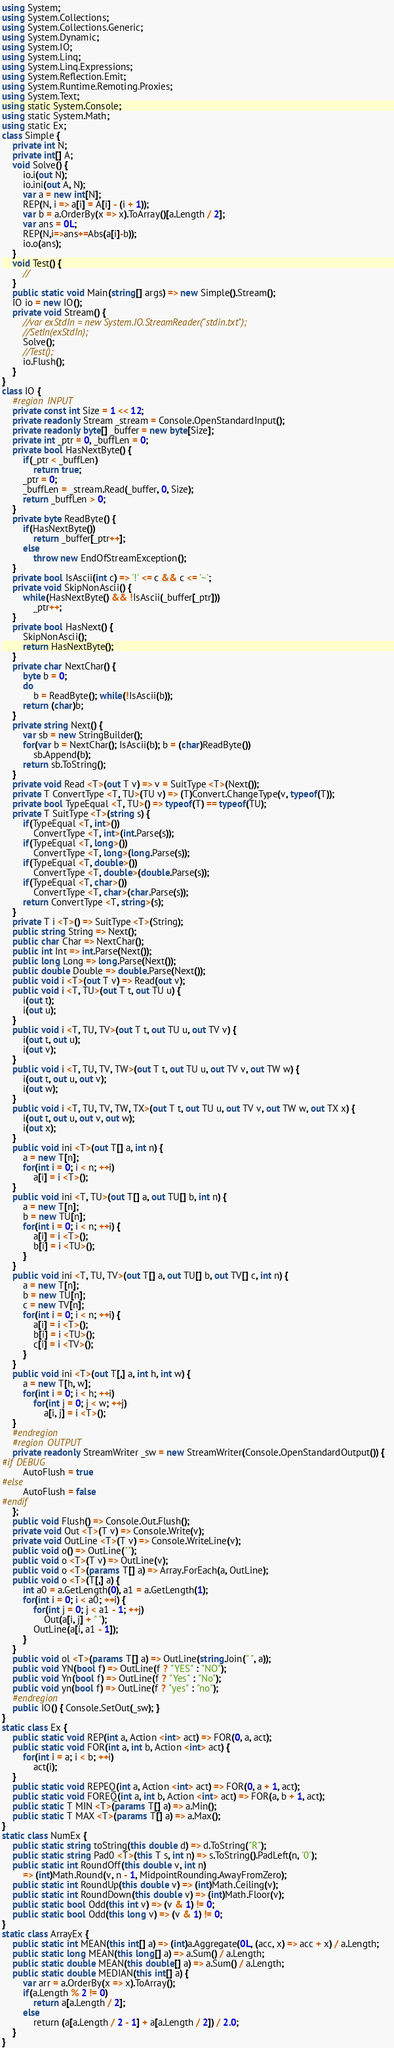Convert code to text. <code><loc_0><loc_0><loc_500><loc_500><_C#_>using System;
using System.Collections;
using System.Collections.Generic;
using System.Dynamic;
using System.IO;
using System.Linq;
using System.Linq.Expressions;
using System.Reflection.Emit;
using System.Runtime.Remoting.Proxies;
using System.Text;
using static System.Console;
using static System.Math;
using static Ex;
class Simple {
    private int N;
    private int[] A;
    void Solve() {
        io.i(out N);
        io.ini(out A, N);
        var a = new int[N];
        REP(N, i => a[i] = A[i] - (i + 1));
        var b = a.OrderBy(x => x).ToArray()[a.Length / 2];
        var ans = 0L;
        REP(N,i=>ans+=Abs(a[i]-b));
        io.o(ans);        
    }
    void Test() {
        //
    }
    public static void Main(string[] args) => new Simple().Stream();
    IO io = new IO();
    private void Stream() {
        //var exStdIn = new System.IO.StreamReader("stdin.txt");
        //SetIn(exStdIn);
        Solve();
        //Test();
        io.Flush();
    }
}
class IO {
    #region INPUT
    private const int Size = 1 << 12;
    private readonly Stream _stream = Console.OpenStandardInput();
    private readonly byte[] _buffer = new byte[Size];
    private int _ptr = 0, _buffLen = 0;
    private bool HasNextByte() {
        if(_ptr < _buffLen)
            return true;
        _ptr = 0;
        _buffLen = _stream.Read(_buffer, 0, Size);
        return _buffLen > 0;
    }
    private byte ReadByte() {
        if(HasNextByte())
            return _buffer[_ptr++];
        else
            throw new EndOfStreamException();
    }
    private bool IsAscii(int c) => '!' <= c && c <= '~';
    private void SkipNonAscii() {
        while(HasNextByte() && !IsAscii(_buffer[_ptr]))
            _ptr++;
    }
    private bool HasNext() {
        SkipNonAscii();
        return HasNextByte();
    }
    private char NextChar() {
        byte b = 0;
        do
            b = ReadByte(); while(!IsAscii(b));
        return (char)b;
    }
    private string Next() {
        var sb = new StringBuilder();
        for(var b = NextChar(); IsAscii(b); b = (char)ReadByte())
            sb.Append(b);
        return sb.ToString();
    }
    private void Read <T>(out T v) => v = SuitType <T>(Next());
    private T ConvertType <T, TU>(TU v) => (T)Convert.ChangeType(v, typeof(T));
    private bool TypeEqual <T, TU>() => typeof(T) == typeof(TU);
    private T SuitType <T>(string s) {
        if(TypeEqual <T, int>())
            ConvertType <T, int>(int.Parse(s));
        if(TypeEqual <T, long>())
            ConvertType <T, long>(long.Parse(s));
        if(TypeEqual <T, double>())
            ConvertType <T, double>(double.Parse(s));
        if(TypeEqual <T, char>())
            ConvertType <T, char>(char.Parse(s));
        return ConvertType <T, string>(s);
    }
    private T i <T>() => SuitType <T>(String);
    public string String => Next();
    public char Char => NextChar();
    public int Int => int.Parse(Next());
    public long Long => long.Parse(Next());
    public double Double => double.Parse(Next());
    public void i <T>(out T v) => Read(out v);
    public void i <T, TU>(out T t, out TU u) {
        i(out t);
        i(out u);
    }
    public void i <T, TU, TV>(out T t, out TU u, out TV v) {
        i(out t, out u);
        i(out v);
    }
    public void i <T, TU, TV, TW>(out T t, out TU u, out TV v, out TW w) {
        i(out t, out u, out v);
        i(out w);
    }
    public void i <T, TU, TV, TW, TX>(out T t, out TU u, out TV v, out TW w, out TX x) {
        i(out t, out u, out v, out w);
        i(out x);
    }
    public void ini <T>(out T[] a, int n) {
        a = new T[n];
        for(int i = 0; i < n; ++i)
            a[i] = i <T>();
    }
    public void ini <T, TU>(out T[] a, out TU[] b, int n) {
        a = new T[n];
        b = new TU[n];
        for(int i = 0; i < n; ++i) {
            a[i] = i <T>();
            b[i] = i <TU>();
        }
    }
    public void ini <T, TU, TV>(out T[] a, out TU[] b, out TV[] c, int n) {
        a = new T[n];
        b = new TU[n];
        c = new TV[n];
        for(int i = 0; i < n; ++i) {
            a[i] = i <T>();
            b[i] = i <TU>();
            c[i] = i <TV>();
        }
    }
    public void ini <T>(out T[,] a, int h, int w) {
        a = new T[h, w];
        for(int i = 0; i < h; ++i)
            for(int j = 0; j < w; ++j)
                a[i, j] = i <T>();
    }
    #endregion
    #region OUTPUT
    private readonly StreamWriter _sw = new StreamWriter(Console.OpenStandardOutput()) {
#if DEBUG
        AutoFlush = true
#else
        AutoFlush = false
#endif
    };
    public void Flush() => Console.Out.Flush();
    private void Out <T>(T v) => Console.Write(v);
    private void OutLine <T>(T v) => Console.WriteLine(v);
    public void o() => OutLine("");
    public void o <T>(T v) => OutLine(v);
    public void o <T>(params T[] a) => Array.ForEach(a, OutLine);
    public void o <T>(T[,] a) {
        int a0 = a.GetLength(0), a1 = a.GetLength(1);
        for(int i = 0; i < a0; ++i) {
            for(int j = 0; j < a1 - 1; ++j)
                Out(a[i, j] + " ");
            OutLine(a[i, a1 - 1]);
        }
    }
    public void ol <T>(params T[] a) => OutLine(string.Join(" ", a));
    public void YN(bool f) => OutLine(f ? "YES" : "NO");
    public void Yn(bool f) => OutLine(f ? "Yes" : "No");
    public void yn(bool f) => OutLine(f ? "yes" : "no");
    #endregion
    public IO() { Console.SetOut(_sw); }
}
static class Ex {
    public static void REP(int a, Action <int> act) => FOR(0, a, act);
    public static void FOR(int a, int b, Action <int> act) {
        for(int i = a; i < b; ++i)
            act(i);
    }
    public static void REPEQ(int a, Action <int> act) => FOR(0, a + 1, act);
    public static void FOREQ(int a, int b, Action <int> act) => FOR(a, b + 1, act);
    public static T MIN <T>(params T[] a) => a.Min();
    public static T MAX <T>(params T[] a) => a.Max();
}
static class NumEx {
    public static string toString(this double d) => d.ToString("R");
    public static string Pad0 <T>(this T s, int n) => s.ToString().PadLeft(n, '0');
    public static int RoundOff(this double v, int n)
        => (int)Math.Round(v, n - 1, MidpointRounding.AwayFromZero);
    public static int RoundUp(this double v) => (int)Math.Ceiling(v);
    public static int RoundDown(this double v) => (int)Math.Floor(v);
    public static bool Odd(this int v) => (v & 1) != 0;
    public static bool Odd(this long v) => (v & 1) != 0;
}
static class ArrayEx {
    public static int MEAN(this int[] a) => (int)a.Aggregate(0L, (acc, x) => acc + x) / a.Length;     
    public static long MEAN(this long[] a) => a.Sum() / a.Length;
    public static double MEAN(this double[] a) => a.Sum() / a.Length;
    public static double MEDIAN(this int[] a) {
        var arr = a.OrderBy(x => x).ToArray();
        if(a.Length % 2 != 0)
            return a[a.Length / 2];
        else        
            return (a[a.Length / 2 - 1] + a[a.Length / 2]) / 2.0;
    }
}</code> 